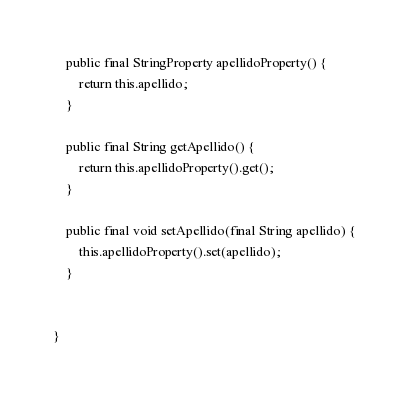Convert code to text. <code><loc_0><loc_0><loc_500><loc_500><_Java_>	public final StringProperty apellidoProperty() {
		return this.apellido;
	}
	
	public final String getApellido() {
		return this.apellidoProperty().get();
	}
	
	public final void setApellido(final String apellido) {
		this.apellidoProperty().set(apellido);
	}
	
	
}
</code> 